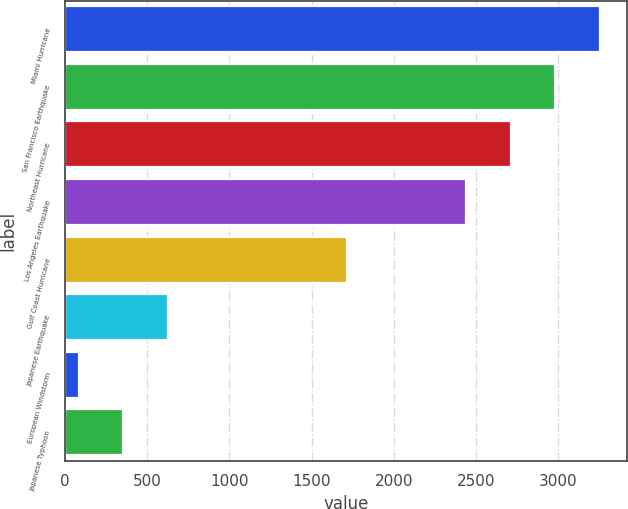<chart> <loc_0><loc_0><loc_500><loc_500><bar_chart><fcel>Miami Hurricane<fcel>San Francisco Earthquake<fcel>Northeast Hurricane<fcel>Los Angeles Earthquake<fcel>Gulf Coast Hurricane<fcel>Japanese Earthquake<fcel>European Windstorm<fcel>Japanese Typhoon<nl><fcel>3254.5<fcel>2983<fcel>2711.5<fcel>2440<fcel>1717<fcel>626<fcel>83<fcel>354.5<nl></chart> 